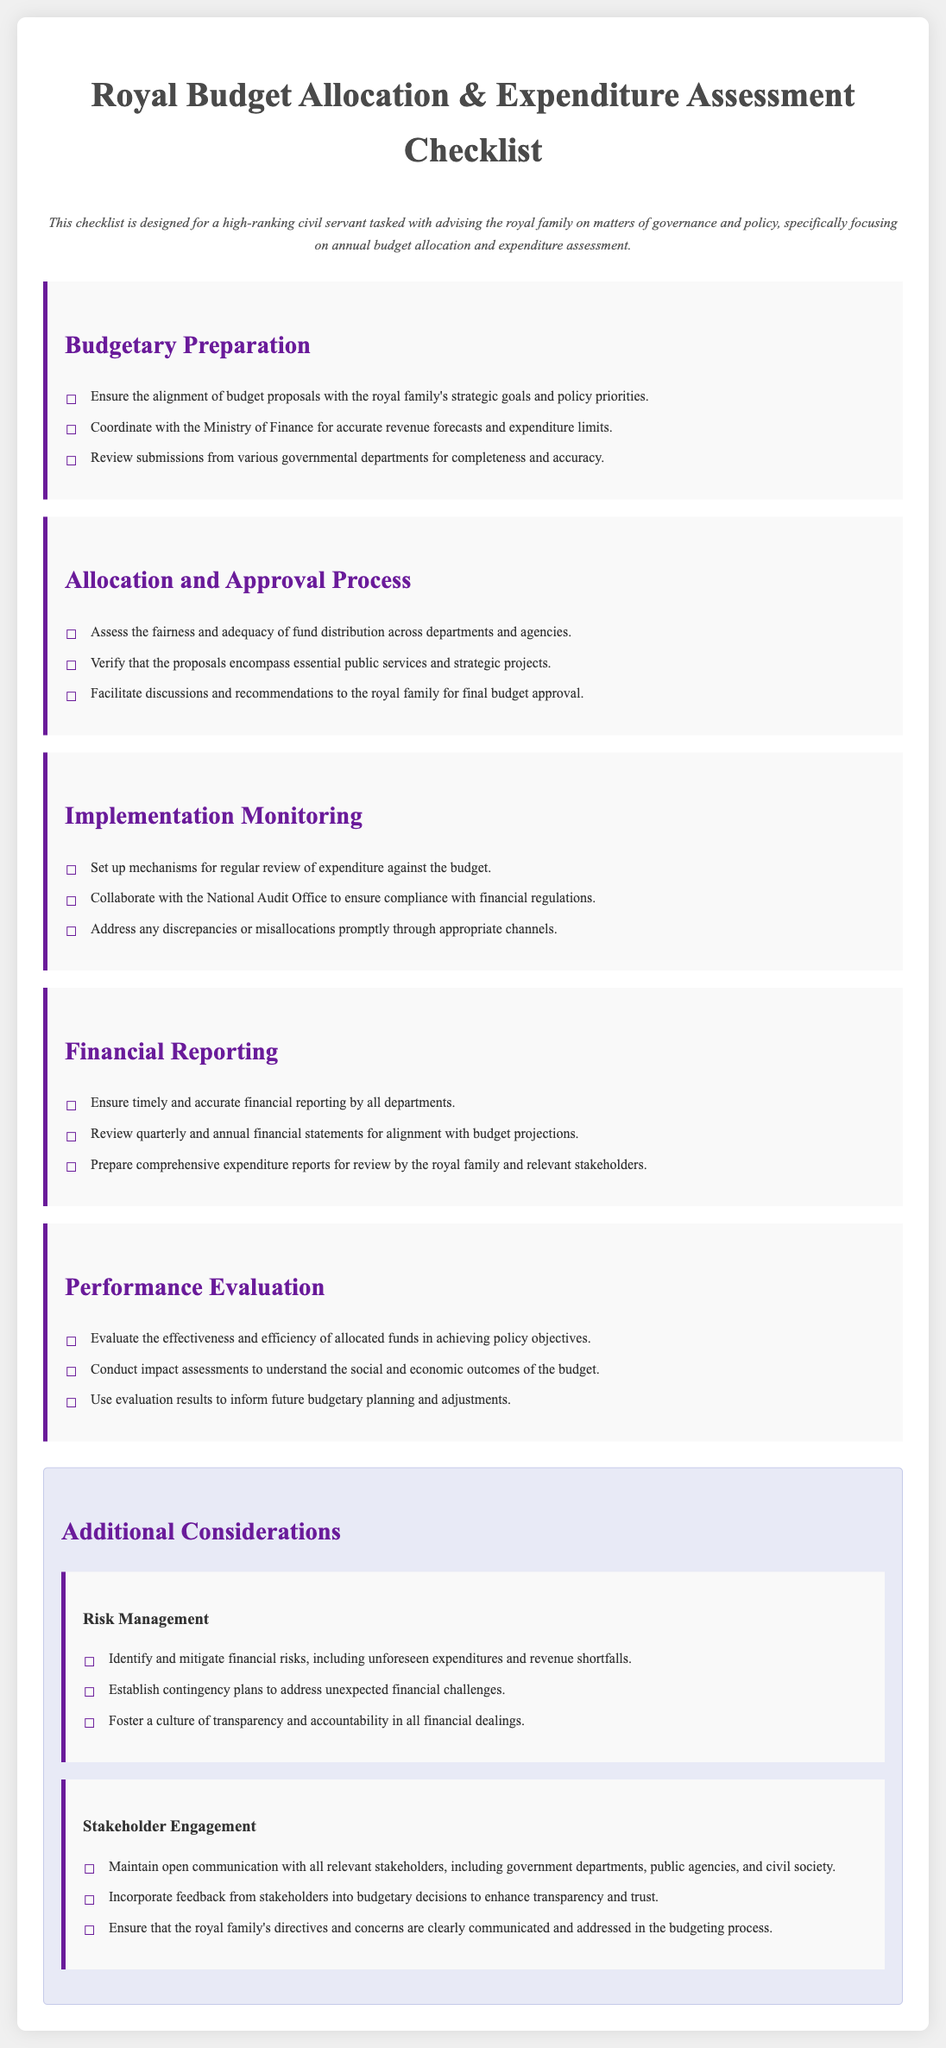What is the title of the document? The title of the document is presented in the header as the main focus of the content.
Answer: Royal Budget Allocation & Expenditure Assessment Checklist Who is the target audience for this checklist? The target audience is indicated in the overview section, specifically mentioning who the document is designed for.
Answer: high-ranking civil servant What section discusses the fairness of fund distribution? The section that addresses the fairness of fund distribution is clearly labeled as part of the budgetary process outlined in the checklist.
Answer: Allocation and Approval Process How many main checklist sections are there? The number of main checklist sections can be counted from the visible headings in the document.
Answer: Five What is one responsibility under Financial Reporting? The responsibilities listed in the Financial Reporting section are specific to ensuring the accuracy and timeliness of financial details.
Answer: Ensure timely and accurate financial reporting by all departments What should be reviewed quarterly and annually? This requirement is specified in the Financial Reporting section, indicating what documents need to be assessed regularly.
Answer: financial statements Which section addresses stakeholder communication? The focus on maintaining stakeholder relationships is mentioned in a specific section emphasizing engagement and interaction in the budgeting process.
Answer: Stakeholder Engagement What is a key aspect of Risk Management? Risk Management highlights essential actions to be taken to handle possible financial uncertainties as stated in the checklist.
Answer: Identify and mitigate financial risks What is mentioned as a tool for evaluating budget outcomes? The effectiveness of allocated funds is discussed in the performance evaluation section, indicating how outcomes should be assessed.
Answer: impact assessments 